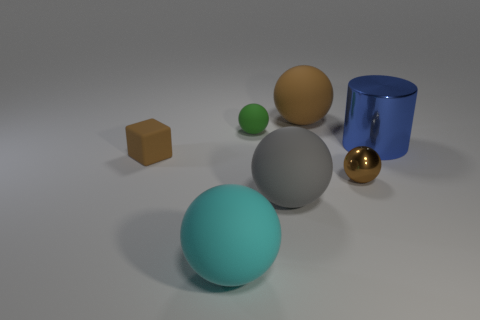Are there any small shiny things of the same color as the small rubber cube?
Offer a terse response. Yes. There is a metal object that is in front of the brown object that is on the left side of the big rubber thing that is in front of the large gray rubber sphere; what is its color?
Offer a very short reply. Brown. Are the cyan thing and the small brown thing on the left side of the small green ball made of the same material?
Give a very brief answer. Yes. What is the cyan ball made of?
Offer a very short reply. Rubber. There is a tiny thing that is the same color as the small block; what material is it?
Keep it short and to the point. Metal. What number of other things are made of the same material as the big blue object?
Offer a very short reply. 1. What shape is the brown thing that is behind the small shiny sphere and in front of the large blue metal object?
Make the answer very short. Cube. There is a tiny cube that is made of the same material as the cyan object; what color is it?
Keep it short and to the point. Brown. Are there an equal number of large brown matte spheres in front of the tiny shiny sphere and small yellow rubber blocks?
Ensure brevity in your answer.  Yes. The gray matte object that is the same size as the blue shiny cylinder is what shape?
Ensure brevity in your answer.  Sphere. 